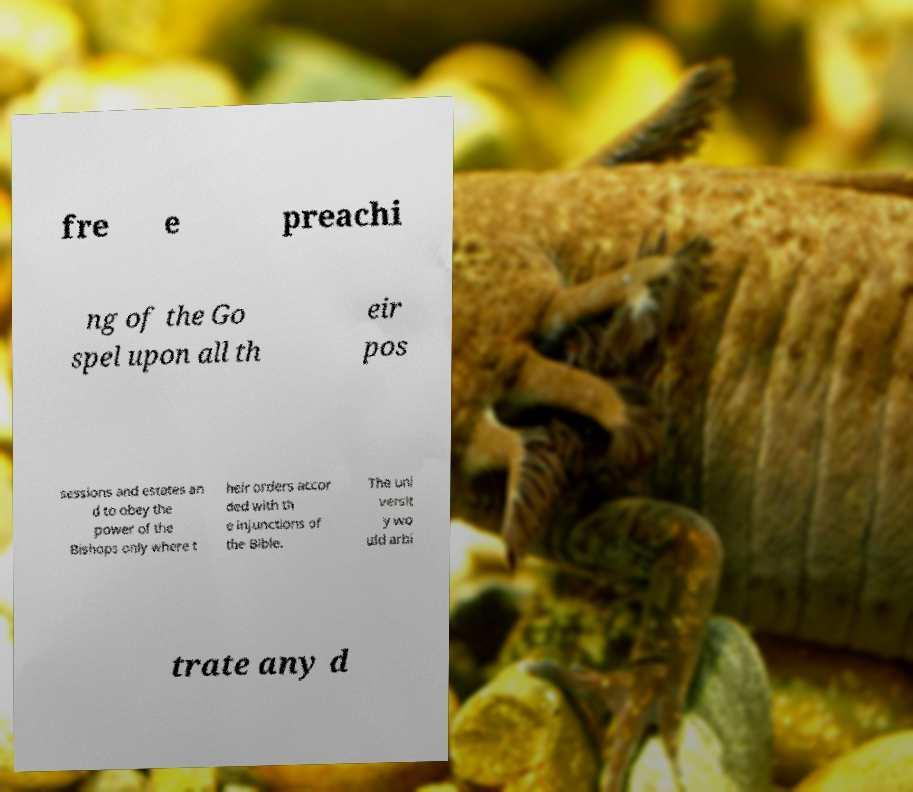There's text embedded in this image that I need extracted. Can you transcribe it verbatim? fre e preachi ng of the Go spel upon all th eir pos sessions and estates an d to obey the power of the Bishops only where t heir orders accor ded with th e injunctions of the Bible. The uni versit y wo uld arbi trate any d 